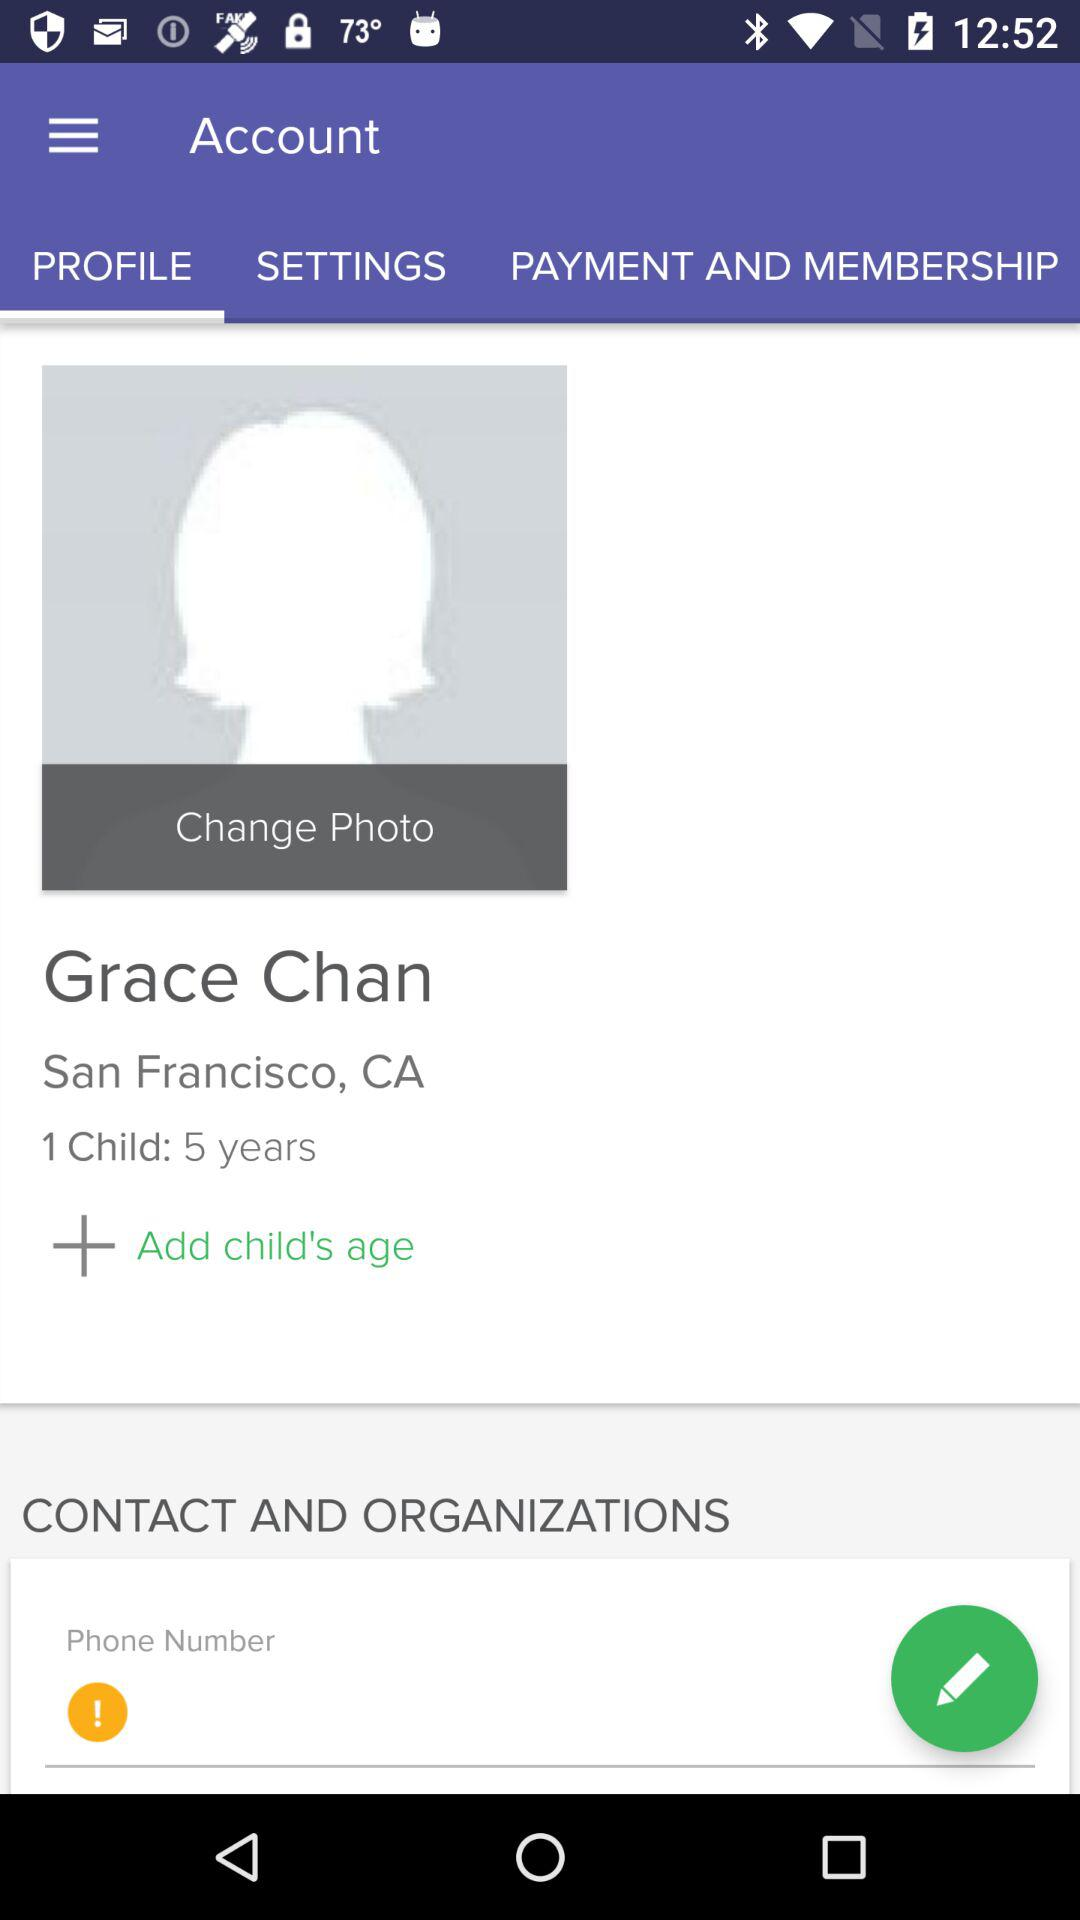Which tab is selected? The selected tab is "PROFILE". 